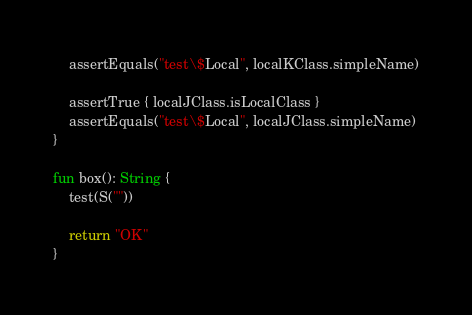<code> <loc_0><loc_0><loc_500><loc_500><_Kotlin_>
    assertEquals("test\$Local", localKClass.simpleName)

    assertTrue { localJClass.isLocalClass }
    assertEquals("test\$Local", localJClass.simpleName)
}

fun box(): String {
    test(S(""))

    return "OK"
}
</code> 